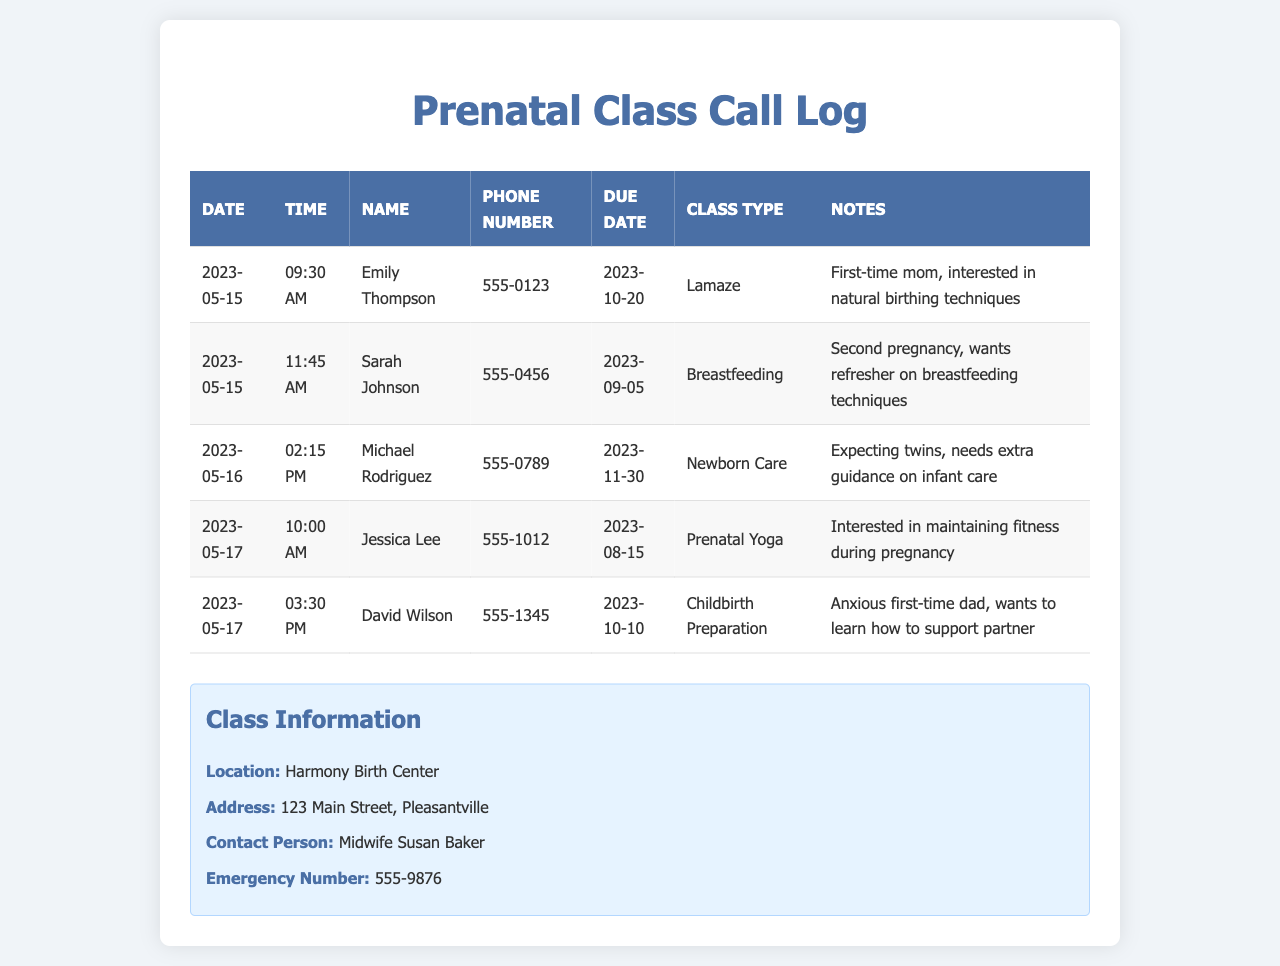what is the name of the first registrant? The first registrant listed in the call log is Emily Thompson.
Answer: Emily Thompson what class type did Sarah Johnson register for? Sarah Johnson registered for a Breastfeeding class.
Answer: Breastfeeding when is Michael Rodriguez's due date? Michael Rodriguez's due date is listed as November 30, 2023.
Answer: 2023-11-30 how many registrations were made on May 17, 2023? On May 17, 2023, there were two registrations recorded.
Answer: 2 which class is David Wilson interested in? David Wilson expressed interest in Childbirth Preparation.
Answer: Childbirth Preparation what is the contact phone number for Emily Thompson? The contact number for Emily Thompson is 555-0123.
Answer: 555-0123 where is the location for the prenatal classes? The location for the prenatal classes is Harmony Birth Center.
Answer: Harmony Birth Center who is the contact person for the prenatal classes? The contact person for the prenatal classes is Midwife Susan Baker.
Answer: Midwife Susan Baker what time did the last call on May 17, 2023, occur? The last call on May 17, 2023, occurred at 3:30 PM.
Answer: 03:30 PM 